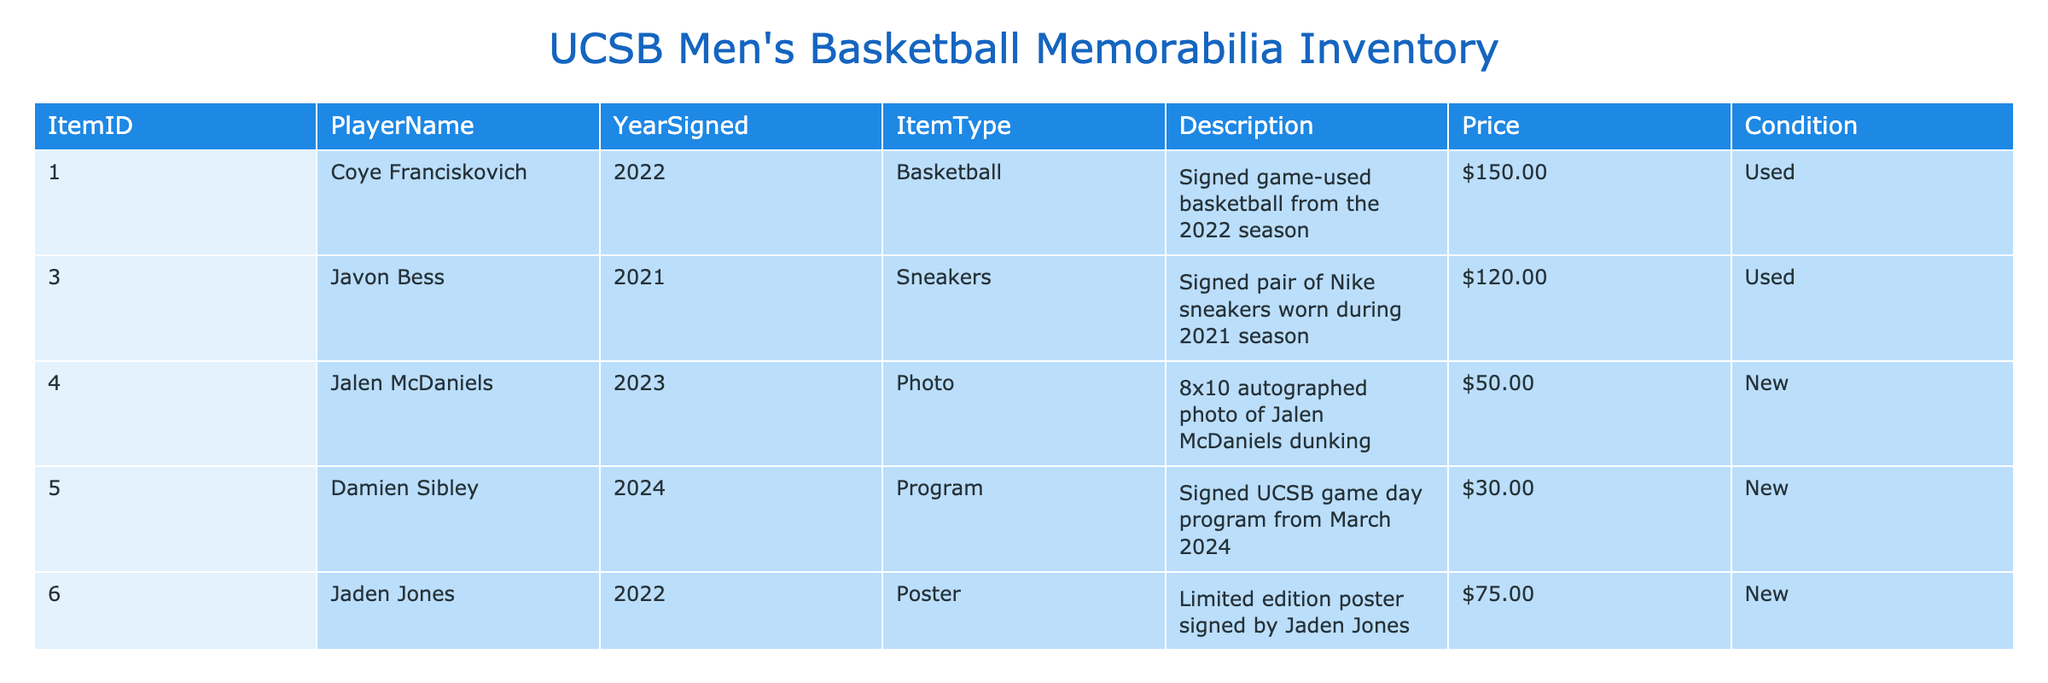What is the price of the signed game-used basketball from Coye Franciskovich? The table shows that the signed game-used basketball from Coye Franciskovich is priced at $150.00.
Answer: $150.00 How many items are available for sale that are in new condition? In the table, there are three items listed with a condition of "New": the photo, program, and poster. Thus, the total is three items.
Answer: 3 What is the total price of all items signed by players in the year 2021? The table lists two items from 2021: the signed pair of sneakers at $120.00 and the official game ball at $250.00. The sum is $120.00 + $250.00 = $370.00.
Answer: $370.00 Is there a signed item available from Jalen McDaniels? Looking at the table, there is one item from Jalen McDaniels, which is an 8x10 autographed photo. Thus, the answer is yes.
Answer: Yes Which item has the highest price, and what is that price? By reviewing the table, the official game ball signed after the 2021 championship game by Amadou Sow is the highest priced at $250.00.
Answer: $250.00 What is the average price of items that are in used condition? The used items listed are the signed basketball at $150.00, signed sneakers at $120.00, and the game ball at $250.00. The average price is calculated as follows: (150 + 120 + 250) / 3 = 520 / 3 = 173.33.
Answer: $173.33 Are there any items signed by players from the year 2024? The table contains one item signed from the year 2024, which is a signed game day program by Damien Sibley. Therefore, the answer is yes.
Answer: Yes What is the total number of signed memorabilia items listed? The table presents a total of seven items available for sale. Counting each entry confirms that there are seven items.
Answer: 7 What condition are the sneakers from Javon Bess in? Referring to the table, the signed pair of Nike sneakers worn during the 2021 season is marked as "Used."
Answer: Used 